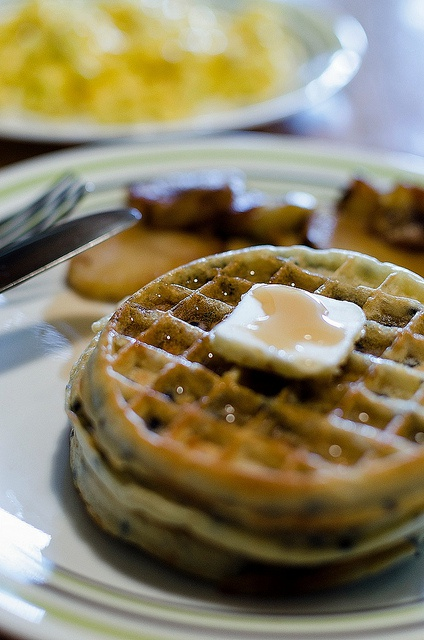Describe the objects in this image and their specific colors. I can see cake in lightgray, olive, black, and maroon tones, knife in lightgray, black, gray, and darkgray tones, and fork in lightgray, gray, black, and darkgray tones in this image. 